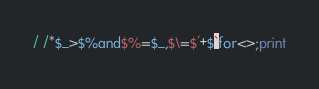<code> <loc_0><loc_0><loc_500><loc_500><_Perl_>/ /*$_>$%and$%=$_,$\=$'+$`for<>;print</code> 